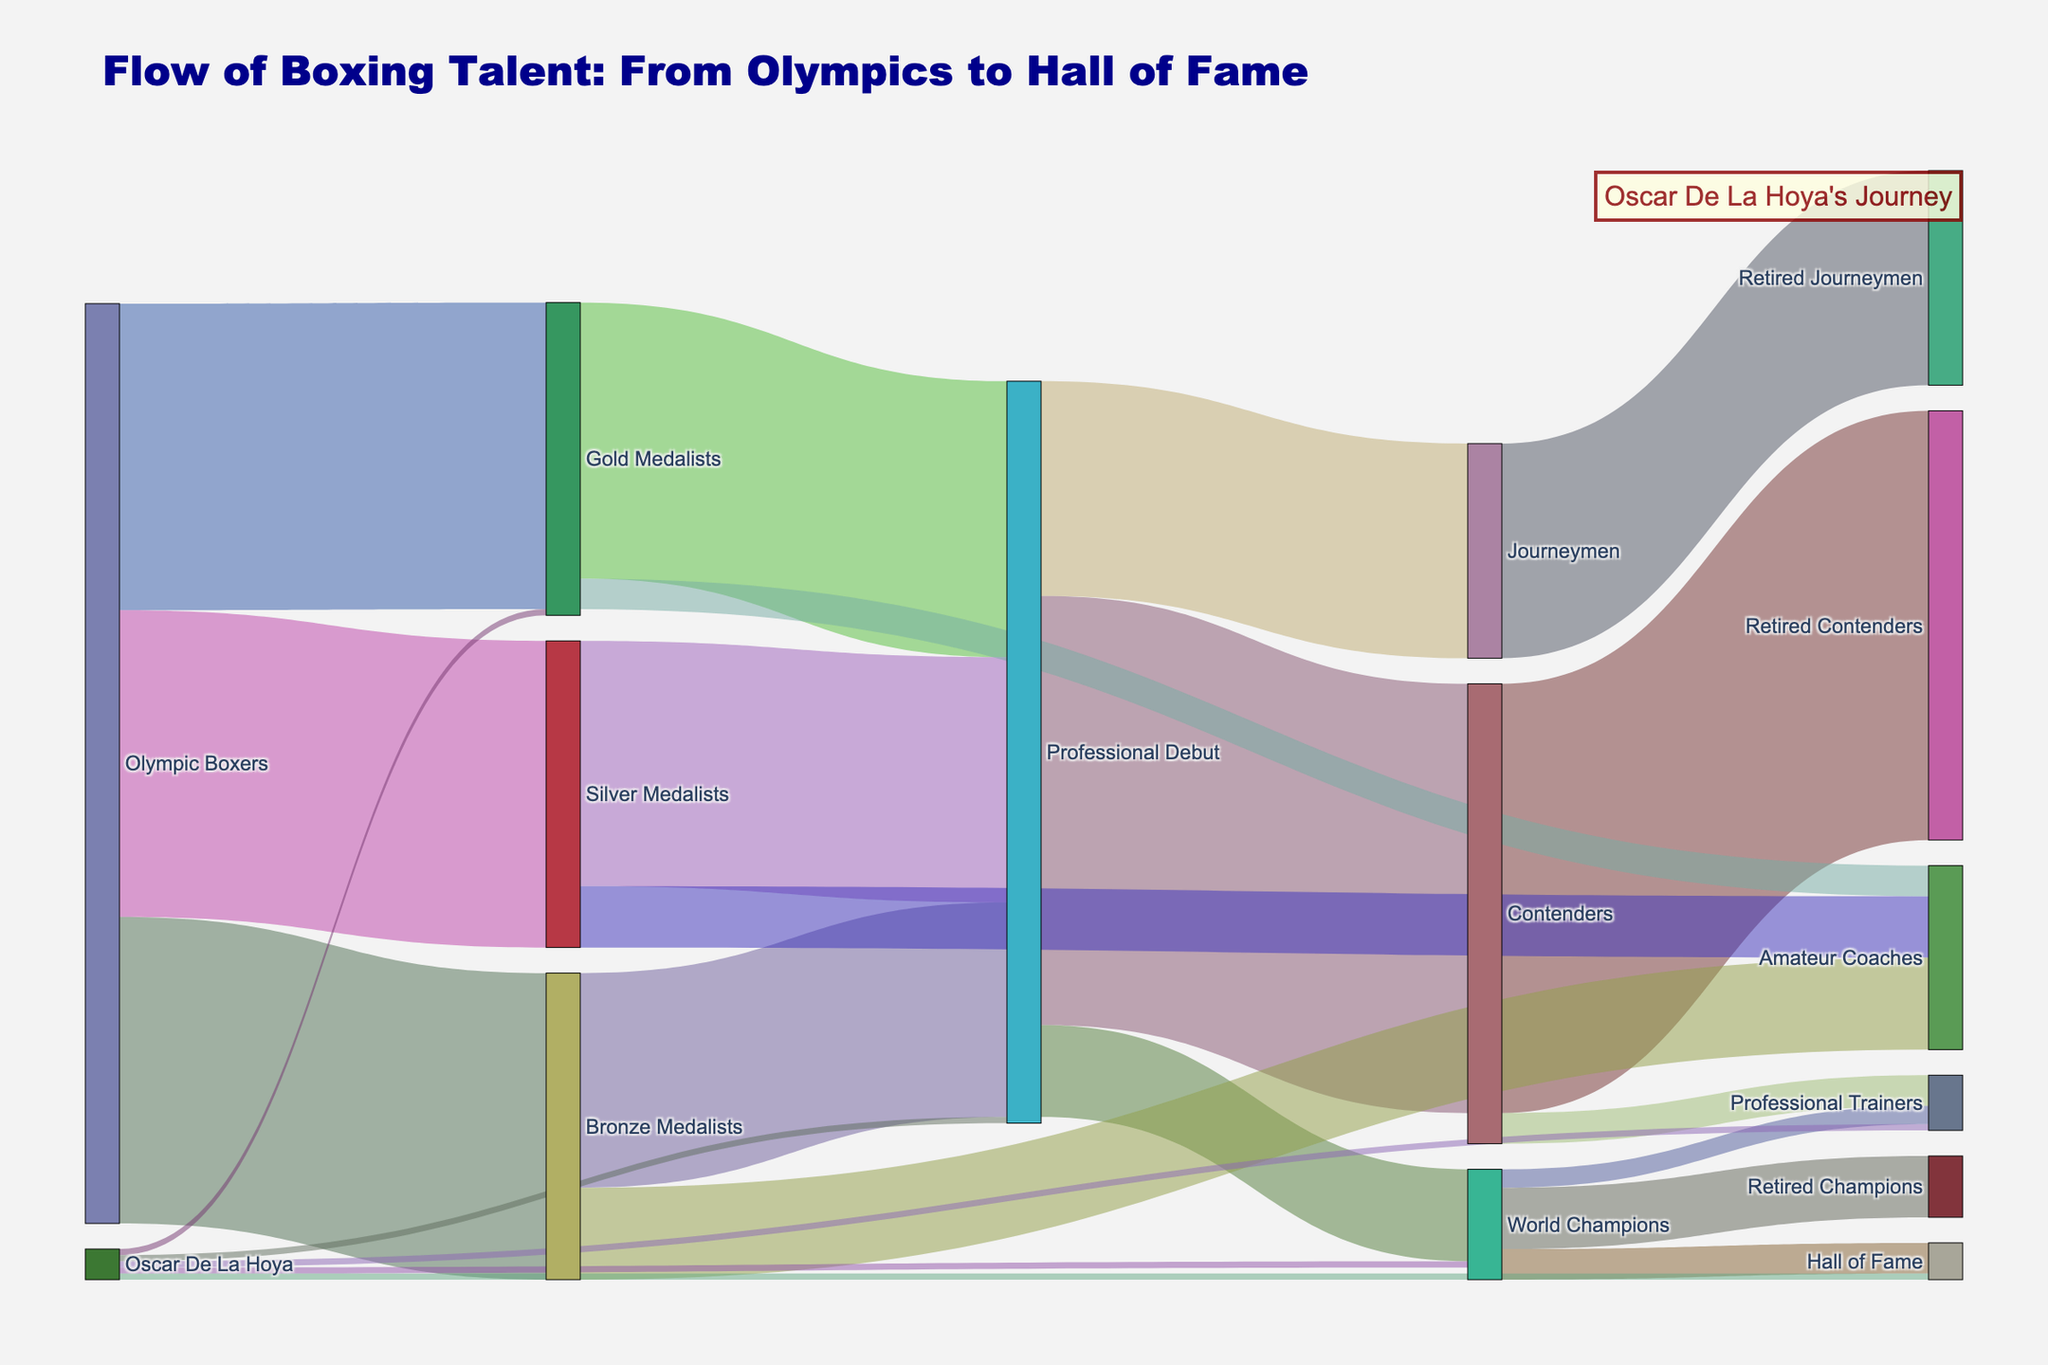What is the title of the figure? The title of the figure is prominently shown at the top, reading "Flow of Boxing Talent: From Olympics to Hall of Fame".
Answer: "Flow of Boxing Talent: From Olympics to Hall of Fame" How many Gold Medalists make their professional debut? To find this information, look at the flow from "Gold Medalists" to "Professional Debut" in the diagram. The value connected between these nodes is 45.
Answer: 45 How many Olympic Silver Medalists become amateurs coaches? Refer to the flow from "Silver Medalists" to "Amateur Coaches". The value connected to these nodes is 10.
Answer: 10 What is the combined number of boxers who became world champions from their professional debut? Sum the values from "Professional Debut" to "World Champions". There is one flow with a value of 15.
Answer: 15 How many boxers transitioned from Silver Medalists to Professional Debut? Look at the value connecting "Silver Medalists" to "Professional Debut". The value here is 40.
Answer: 40 Which stage has the highest transition value from Professional Debut and what is it? Check the values flowing out from "Professional Debut". The highest value of 70 flows to "Contenders".
Answer: Contenders with 70 How many Olympic Boxing Gold Medalists eventually turn into Amateur Coaches or Professional Trainers? Sum the values from "Gold Medalists" to "Amateur Coaches" and to "Professional Trainers". The respective values are 5 and 3, thus 5 + 3 = 8.
Answer: 8 Compare the total number of boxers who became Journeymen to those who became Contenders. Which group is larger? Look at the flows from "Professional Debut" to "Journeymen" (35) and to "Contenders" (70). Contenders is larger with 70.
Answer: Contenders In which stages is Oscar De La Hoya shown? Oscar De La Hoya is shown in "Gold Medalists", "Professional Debut", "World Champions", "Hall of Fame", and "Professional Trainers" streams.
Answer: 5 stages How many Olympic Boxers did not medal? To get this, subtract the sum of all medalists (Gold, Silver, Bronze) from the total number of Olympic Boxers. Given values are 50 Gold, 50 Silver, and 50 Bronze, summing to 150. If non-medalists = Olympic Boxers - medalists, then look for missing base data as for raw values omitted above setup - this total analysis clarifies all won medals with no designate remaining non-medal individuals shown.
Answer: Data for non-medalists is not provided 